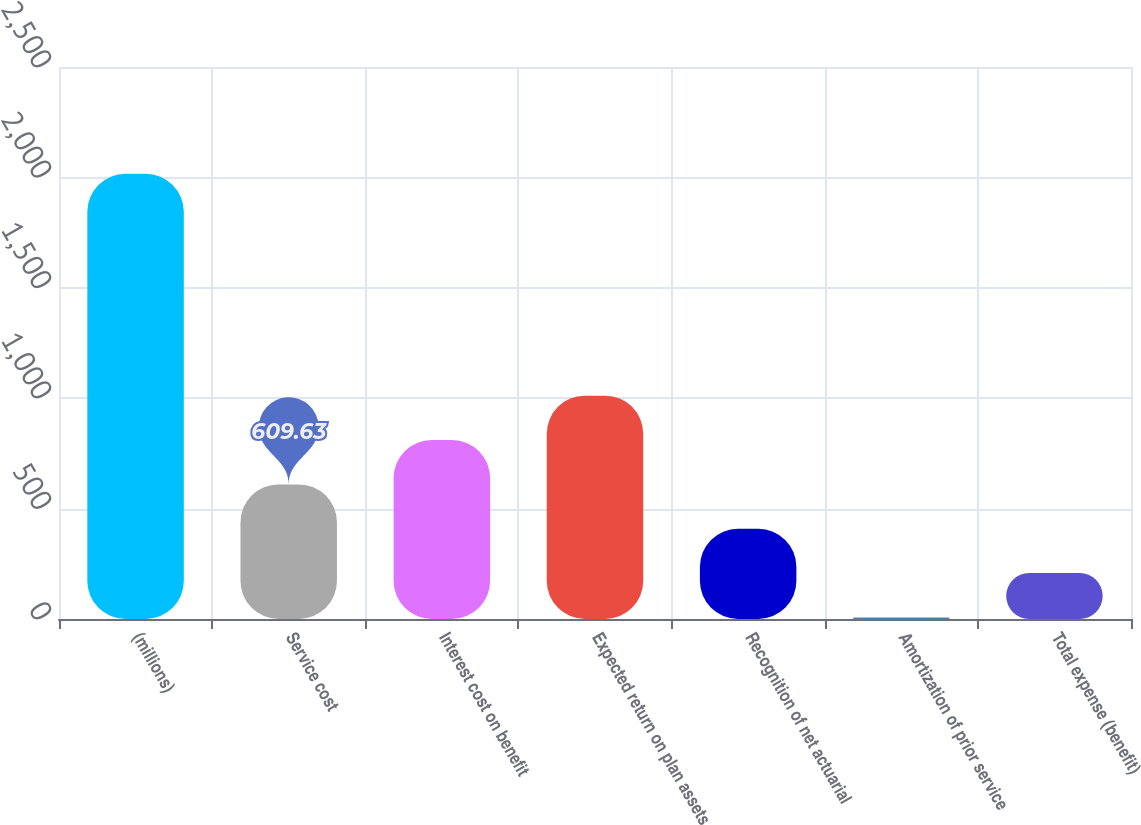Convert chart. <chart><loc_0><loc_0><loc_500><loc_500><bar_chart><fcel>(millions)<fcel>Service cost<fcel>Interest cost on benefit<fcel>Expected return on plan assets<fcel>Recognition of net actuarial<fcel>Amortization of prior service<fcel>Total expense (benefit)<nl><fcel>2016<fcel>609.63<fcel>810.54<fcel>1011.45<fcel>408.72<fcel>6.9<fcel>207.81<nl></chart> 